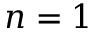Convert formula to latex. <formula><loc_0><loc_0><loc_500><loc_500>n = 1</formula> 